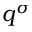Convert formula to latex. <formula><loc_0><loc_0><loc_500><loc_500>q ^ { \sigma }</formula> 